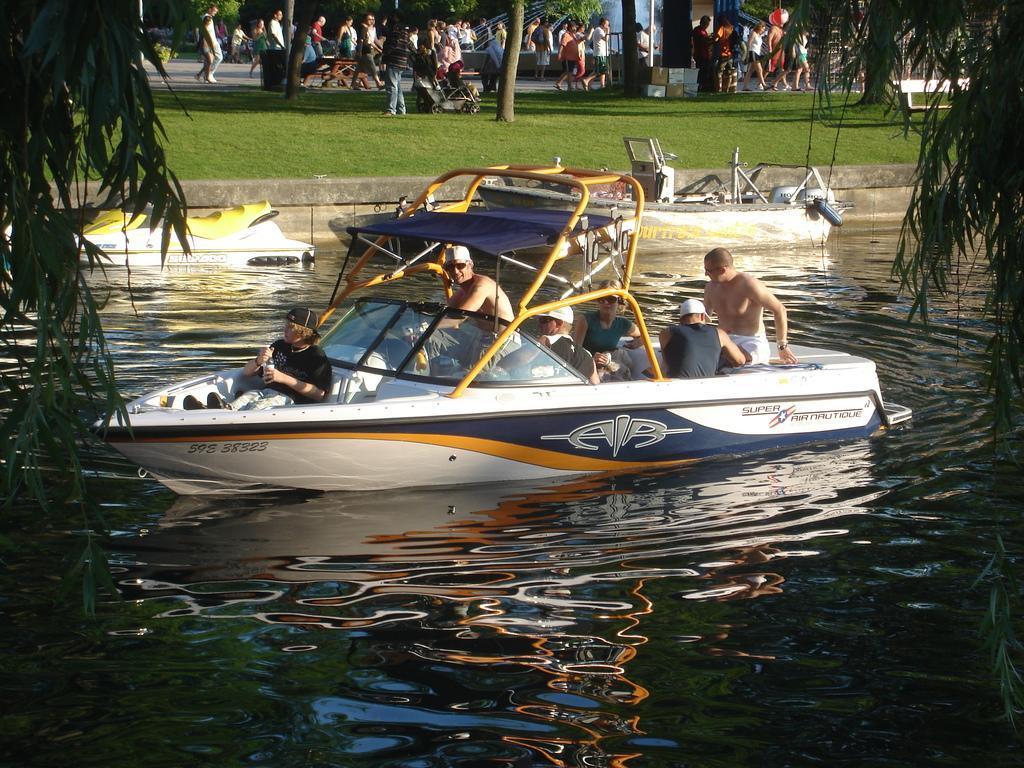Can you describe this image briefly? In this image there are three boats on a canal, on one boat there are people sitting, in the background there is a grassland in that land there are trees and people are walking on a pavement, on the top left and top right there are leaves. 